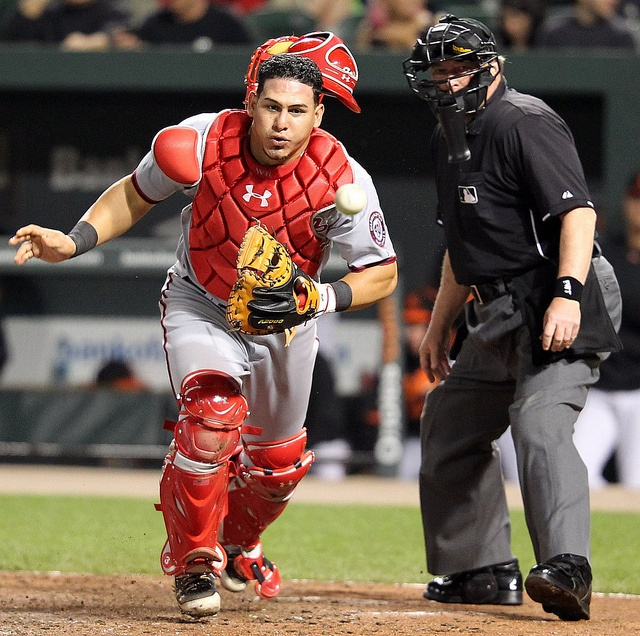Describe the objects in this image and their specific colors. I can see people in black, maroon, brown, lightgray, and gray tones, people in black, gray, and maroon tones, people in black, lavender, darkgray, and maroon tones, baseball glove in black, gold, maroon, and gray tones, and people in black, maroon, darkgray, and brown tones in this image. 